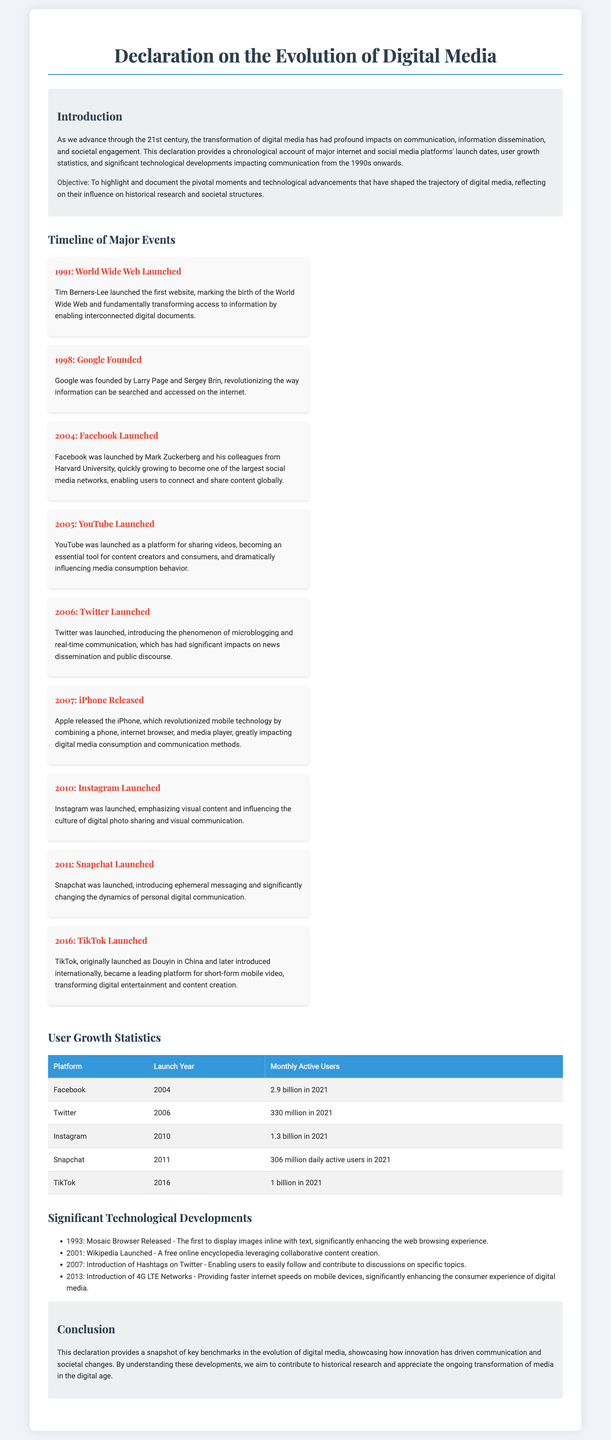What year was the World Wide Web launched? The document states that the World Wide Web was launched in 1991.
Answer: 1991 Who founded Google? According to the document, Google was founded by Larry Page and Sergey Brin.
Answer: Larry Page and Sergey Brin What platform was launched in 2010? The declaration mentions that Instagram was launched in 2010.
Answer: Instagram How many monthly active users did Facebook have in 2021? The document indicates that Facebook had 2.9 billion monthly active users in 2021.
Answer: 2.9 billion What significant technological development occurred in 2001? The document states that Wikipedia was launched in 2001 as a significant technological development.
Answer: Wikipedia Launched Which platform introduced ephemeral messaging? According to the declaration, Snapchat introduced ephemeral messaging in 2011.
Answer: Snapchat What was a key impact of the iPhone's release? The document highlights that the iPhone revolutionized mobile technology, impacting digital media consumption and communication methods.
Answer: Revolutionized mobile technology What is the main objective of the declaration? The document outlines its objective as highlighting and documenting pivotal moments and technological advancements that shaped the trajectory of digital media.
Answer: Highlighting pivotal moments How did the introduction of 4G LTE networks affect media? According to the document, 4G LTE networks provided faster internet speeds, enhancing the consumer experience of digital media.
Answer: Enhanced consumer experience 